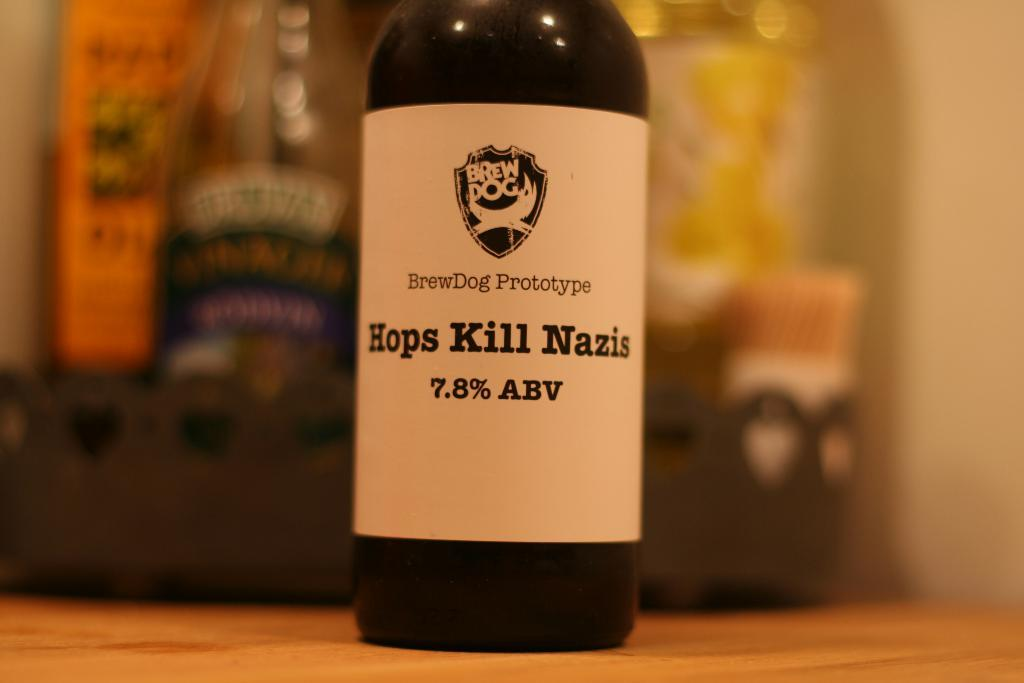<image>
Relay a brief, clear account of the picture shown. A black bottle with a white label that reads "Hops Kill Nazis." 